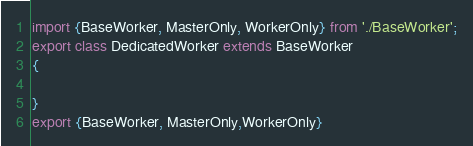<code> <loc_0><loc_0><loc_500><loc_500><_JavaScript_>import {BaseWorker, MasterOnly, WorkerOnly} from './BaseWorker';
export class DedicatedWorker extends BaseWorker
{

}
export {BaseWorker, MasterOnly,WorkerOnly}</code> 